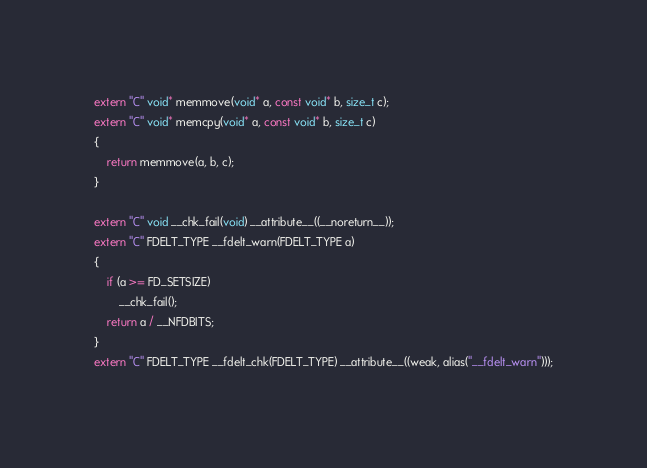<code> <loc_0><loc_0><loc_500><loc_500><_C++_>extern "C" void* memmove(void* a, const void* b, size_t c);
extern "C" void* memcpy(void* a, const void* b, size_t c)
{
    return memmove(a, b, c);
}

extern "C" void __chk_fail(void) __attribute__((__noreturn__));
extern "C" FDELT_TYPE __fdelt_warn(FDELT_TYPE a)
{
    if (a >= FD_SETSIZE)
        __chk_fail();
    return a / __NFDBITS;
}
extern "C" FDELT_TYPE __fdelt_chk(FDELT_TYPE) __attribute__((weak, alias("__fdelt_warn")));
</code> 